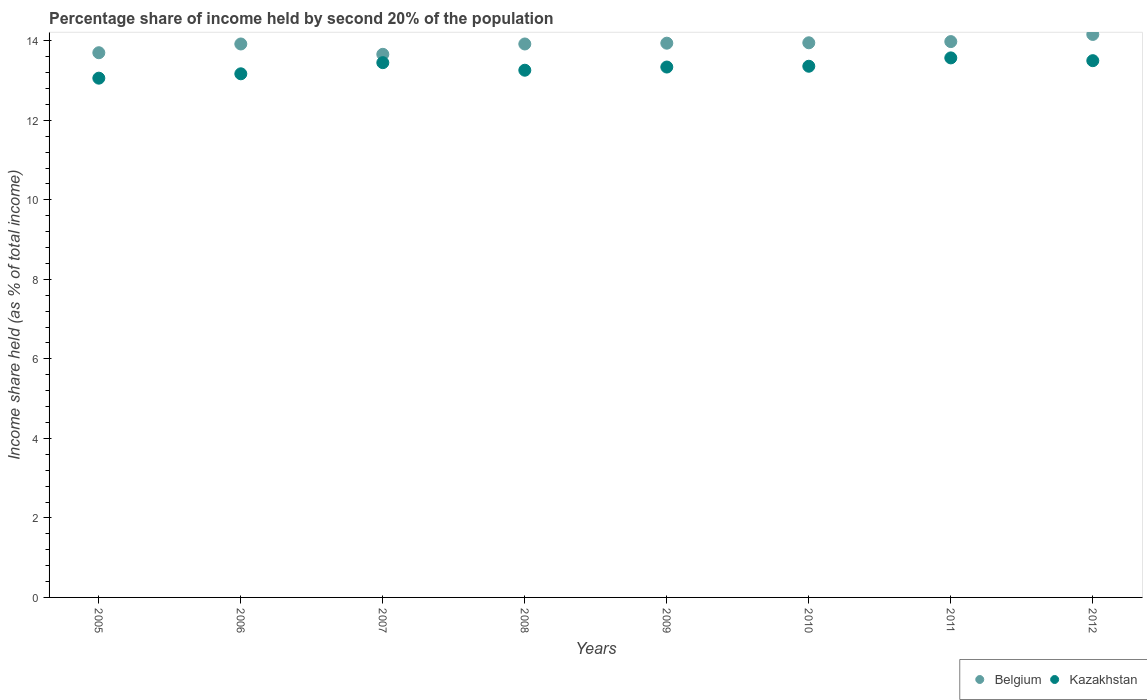How many different coloured dotlines are there?
Your answer should be compact. 2. Is the number of dotlines equal to the number of legend labels?
Give a very brief answer. Yes. What is the share of income held by second 20% of the population in Belgium in 2009?
Offer a very short reply. 13.94. Across all years, what is the maximum share of income held by second 20% of the population in Kazakhstan?
Give a very brief answer. 13.57. Across all years, what is the minimum share of income held by second 20% of the population in Kazakhstan?
Your answer should be compact. 13.06. What is the total share of income held by second 20% of the population in Kazakhstan in the graph?
Provide a succinct answer. 106.71. What is the difference between the share of income held by second 20% of the population in Belgium in 2009 and that in 2011?
Make the answer very short. -0.04. What is the difference between the share of income held by second 20% of the population in Belgium in 2009 and the share of income held by second 20% of the population in Kazakhstan in 2008?
Provide a succinct answer. 0.68. What is the average share of income held by second 20% of the population in Kazakhstan per year?
Offer a very short reply. 13.34. In the year 2010, what is the difference between the share of income held by second 20% of the population in Kazakhstan and share of income held by second 20% of the population in Belgium?
Your answer should be very brief. -0.59. What is the ratio of the share of income held by second 20% of the population in Kazakhstan in 2007 to that in 2008?
Keep it short and to the point. 1.01. What is the difference between the highest and the second highest share of income held by second 20% of the population in Kazakhstan?
Provide a short and direct response. 0.07. What is the difference between the highest and the lowest share of income held by second 20% of the population in Kazakhstan?
Provide a short and direct response. 0.51. In how many years, is the share of income held by second 20% of the population in Kazakhstan greater than the average share of income held by second 20% of the population in Kazakhstan taken over all years?
Provide a short and direct response. 5. Is the sum of the share of income held by second 20% of the population in Belgium in 2008 and 2011 greater than the maximum share of income held by second 20% of the population in Kazakhstan across all years?
Provide a short and direct response. Yes. Is the share of income held by second 20% of the population in Belgium strictly greater than the share of income held by second 20% of the population in Kazakhstan over the years?
Ensure brevity in your answer.  Yes. What is the difference between two consecutive major ticks on the Y-axis?
Provide a succinct answer. 2. Does the graph contain any zero values?
Your answer should be compact. No. Where does the legend appear in the graph?
Offer a terse response. Bottom right. How are the legend labels stacked?
Offer a terse response. Horizontal. What is the title of the graph?
Your answer should be compact. Percentage share of income held by second 20% of the population. Does "Liberia" appear as one of the legend labels in the graph?
Make the answer very short. No. What is the label or title of the X-axis?
Your response must be concise. Years. What is the label or title of the Y-axis?
Give a very brief answer. Income share held (as % of total income). What is the Income share held (as % of total income) of Belgium in 2005?
Give a very brief answer. 13.7. What is the Income share held (as % of total income) of Kazakhstan in 2005?
Provide a short and direct response. 13.06. What is the Income share held (as % of total income) in Belgium in 2006?
Your answer should be very brief. 13.92. What is the Income share held (as % of total income) in Kazakhstan in 2006?
Keep it short and to the point. 13.17. What is the Income share held (as % of total income) of Belgium in 2007?
Provide a short and direct response. 13.66. What is the Income share held (as % of total income) in Kazakhstan in 2007?
Ensure brevity in your answer.  13.45. What is the Income share held (as % of total income) in Belgium in 2008?
Make the answer very short. 13.92. What is the Income share held (as % of total income) of Kazakhstan in 2008?
Provide a succinct answer. 13.26. What is the Income share held (as % of total income) in Belgium in 2009?
Provide a succinct answer. 13.94. What is the Income share held (as % of total income) of Kazakhstan in 2009?
Give a very brief answer. 13.34. What is the Income share held (as % of total income) of Belgium in 2010?
Give a very brief answer. 13.95. What is the Income share held (as % of total income) in Kazakhstan in 2010?
Your answer should be compact. 13.36. What is the Income share held (as % of total income) in Belgium in 2011?
Give a very brief answer. 13.98. What is the Income share held (as % of total income) of Kazakhstan in 2011?
Provide a short and direct response. 13.57. What is the Income share held (as % of total income) in Belgium in 2012?
Your response must be concise. 14.16. What is the Income share held (as % of total income) of Kazakhstan in 2012?
Offer a very short reply. 13.5. Across all years, what is the maximum Income share held (as % of total income) in Belgium?
Provide a succinct answer. 14.16. Across all years, what is the maximum Income share held (as % of total income) of Kazakhstan?
Keep it short and to the point. 13.57. Across all years, what is the minimum Income share held (as % of total income) in Belgium?
Give a very brief answer. 13.66. Across all years, what is the minimum Income share held (as % of total income) of Kazakhstan?
Give a very brief answer. 13.06. What is the total Income share held (as % of total income) in Belgium in the graph?
Your response must be concise. 111.23. What is the total Income share held (as % of total income) in Kazakhstan in the graph?
Make the answer very short. 106.71. What is the difference between the Income share held (as % of total income) in Belgium in 2005 and that in 2006?
Provide a short and direct response. -0.22. What is the difference between the Income share held (as % of total income) of Kazakhstan in 2005 and that in 2006?
Your answer should be compact. -0.11. What is the difference between the Income share held (as % of total income) in Kazakhstan in 2005 and that in 2007?
Offer a terse response. -0.39. What is the difference between the Income share held (as % of total income) in Belgium in 2005 and that in 2008?
Provide a short and direct response. -0.22. What is the difference between the Income share held (as % of total income) in Belgium in 2005 and that in 2009?
Make the answer very short. -0.24. What is the difference between the Income share held (as % of total income) in Kazakhstan in 2005 and that in 2009?
Make the answer very short. -0.28. What is the difference between the Income share held (as % of total income) in Kazakhstan in 2005 and that in 2010?
Provide a short and direct response. -0.3. What is the difference between the Income share held (as % of total income) in Belgium in 2005 and that in 2011?
Give a very brief answer. -0.28. What is the difference between the Income share held (as % of total income) of Kazakhstan in 2005 and that in 2011?
Make the answer very short. -0.51. What is the difference between the Income share held (as % of total income) in Belgium in 2005 and that in 2012?
Your response must be concise. -0.46. What is the difference between the Income share held (as % of total income) of Kazakhstan in 2005 and that in 2012?
Give a very brief answer. -0.44. What is the difference between the Income share held (as % of total income) of Belgium in 2006 and that in 2007?
Make the answer very short. 0.26. What is the difference between the Income share held (as % of total income) in Kazakhstan in 2006 and that in 2007?
Offer a very short reply. -0.28. What is the difference between the Income share held (as % of total income) in Kazakhstan in 2006 and that in 2008?
Make the answer very short. -0.09. What is the difference between the Income share held (as % of total income) of Belgium in 2006 and that in 2009?
Make the answer very short. -0.02. What is the difference between the Income share held (as % of total income) in Kazakhstan in 2006 and that in 2009?
Your answer should be very brief. -0.17. What is the difference between the Income share held (as % of total income) of Belgium in 2006 and that in 2010?
Keep it short and to the point. -0.03. What is the difference between the Income share held (as % of total income) of Kazakhstan in 2006 and that in 2010?
Make the answer very short. -0.19. What is the difference between the Income share held (as % of total income) of Belgium in 2006 and that in 2011?
Provide a succinct answer. -0.06. What is the difference between the Income share held (as % of total income) in Kazakhstan in 2006 and that in 2011?
Make the answer very short. -0.4. What is the difference between the Income share held (as % of total income) of Belgium in 2006 and that in 2012?
Make the answer very short. -0.24. What is the difference between the Income share held (as % of total income) of Kazakhstan in 2006 and that in 2012?
Provide a succinct answer. -0.33. What is the difference between the Income share held (as % of total income) in Belgium in 2007 and that in 2008?
Offer a terse response. -0.26. What is the difference between the Income share held (as % of total income) in Kazakhstan in 2007 and that in 2008?
Keep it short and to the point. 0.19. What is the difference between the Income share held (as % of total income) of Belgium in 2007 and that in 2009?
Your answer should be very brief. -0.28. What is the difference between the Income share held (as % of total income) of Kazakhstan in 2007 and that in 2009?
Give a very brief answer. 0.11. What is the difference between the Income share held (as % of total income) in Belgium in 2007 and that in 2010?
Offer a terse response. -0.29. What is the difference between the Income share held (as % of total income) in Kazakhstan in 2007 and that in 2010?
Offer a terse response. 0.09. What is the difference between the Income share held (as % of total income) of Belgium in 2007 and that in 2011?
Offer a very short reply. -0.32. What is the difference between the Income share held (as % of total income) in Kazakhstan in 2007 and that in 2011?
Your answer should be compact. -0.12. What is the difference between the Income share held (as % of total income) in Belgium in 2007 and that in 2012?
Provide a succinct answer. -0.5. What is the difference between the Income share held (as % of total income) of Kazakhstan in 2007 and that in 2012?
Your answer should be very brief. -0.05. What is the difference between the Income share held (as % of total income) in Belgium in 2008 and that in 2009?
Your answer should be compact. -0.02. What is the difference between the Income share held (as % of total income) in Kazakhstan in 2008 and that in 2009?
Provide a short and direct response. -0.08. What is the difference between the Income share held (as % of total income) in Belgium in 2008 and that in 2010?
Your answer should be compact. -0.03. What is the difference between the Income share held (as % of total income) of Kazakhstan in 2008 and that in 2010?
Offer a very short reply. -0.1. What is the difference between the Income share held (as % of total income) in Belgium in 2008 and that in 2011?
Keep it short and to the point. -0.06. What is the difference between the Income share held (as % of total income) of Kazakhstan in 2008 and that in 2011?
Keep it short and to the point. -0.31. What is the difference between the Income share held (as % of total income) of Belgium in 2008 and that in 2012?
Offer a terse response. -0.24. What is the difference between the Income share held (as % of total income) of Kazakhstan in 2008 and that in 2012?
Your answer should be compact. -0.24. What is the difference between the Income share held (as % of total income) of Belgium in 2009 and that in 2010?
Your answer should be very brief. -0.01. What is the difference between the Income share held (as % of total income) in Kazakhstan in 2009 and that in 2010?
Offer a terse response. -0.02. What is the difference between the Income share held (as % of total income) of Belgium in 2009 and that in 2011?
Provide a succinct answer. -0.04. What is the difference between the Income share held (as % of total income) in Kazakhstan in 2009 and that in 2011?
Provide a succinct answer. -0.23. What is the difference between the Income share held (as % of total income) of Belgium in 2009 and that in 2012?
Provide a succinct answer. -0.22. What is the difference between the Income share held (as % of total income) of Kazakhstan in 2009 and that in 2012?
Ensure brevity in your answer.  -0.16. What is the difference between the Income share held (as % of total income) in Belgium in 2010 and that in 2011?
Offer a very short reply. -0.03. What is the difference between the Income share held (as % of total income) in Kazakhstan in 2010 and that in 2011?
Keep it short and to the point. -0.21. What is the difference between the Income share held (as % of total income) of Belgium in 2010 and that in 2012?
Offer a very short reply. -0.21. What is the difference between the Income share held (as % of total income) in Kazakhstan in 2010 and that in 2012?
Ensure brevity in your answer.  -0.14. What is the difference between the Income share held (as % of total income) in Belgium in 2011 and that in 2012?
Your answer should be very brief. -0.18. What is the difference between the Income share held (as % of total income) of Kazakhstan in 2011 and that in 2012?
Provide a short and direct response. 0.07. What is the difference between the Income share held (as % of total income) of Belgium in 2005 and the Income share held (as % of total income) of Kazakhstan in 2006?
Provide a succinct answer. 0.53. What is the difference between the Income share held (as % of total income) in Belgium in 2005 and the Income share held (as % of total income) in Kazakhstan in 2008?
Offer a terse response. 0.44. What is the difference between the Income share held (as % of total income) of Belgium in 2005 and the Income share held (as % of total income) of Kazakhstan in 2009?
Offer a terse response. 0.36. What is the difference between the Income share held (as % of total income) of Belgium in 2005 and the Income share held (as % of total income) of Kazakhstan in 2010?
Your answer should be compact. 0.34. What is the difference between the Income share held (as % of total income) of Belgium in 2005 and the Income share held (as % of total income) of Kazakhstan in 2011?
Make the answer very short. 0.13. What is the difference between the Income share held (as % of total income) of Belgium in 2006 and the Income share held (as % of total income) of Kazakhstan in 2007?
Provide a short and direct response. 0.47. What is the difference between the Income share held (as % of total income) of Belgium in 2006 and the Income share held (as % of total income) of Kazakhstan in 2008?
Your response must be concise. 0.66. What is the difference between the Income share held (as % of total income) in Belgium in 2006 and the Income share held (as % of total income) in Kazakhstan in 2009?
Ensure brevity in your answer.  0.58. What is the difference between the Income share held (as % of total income) in Belgium in 2006 and the Income share held (as % of total income) in Kazakhstan in 2010?
Provide a succinct answer. 0.56. What is the difference between the Income share held (as % of total income) in Belgium in 2006 and the Income share held (as % of total income) in Kazakhstan in 2012?
Your response must be concise. 0.42. What is the difference between the Income share held (as % of total income) of Belgium in 2007 and the Income share held (as % of total income) of Kazakhstan in 2009?
Provide a succinct answer. 0.32. What is the difference between the Income share held (as % of total income) in Belgium in 2007 and the Income share held (as % of total income) in Kazakhstan in 2010?
Offer a terse response. 0.3. What is the difference between the Income share held (as % of total income) of Belgium in 2007 and the Income share held (as % of total income) of Kazakhstan in 2011?
Ensure brevity in your answer.  0.09. What is the difference between the Income share held (as % of total income) of Belgium in 2007 and the Income share held (as % of total income) of Kazakhstan in 2012?
Provide a short and direct response. 0.16. What is the difference between the Income share held (as % of total income) of Belgium in 2008 and the Income share held (as % of total income) of Kazakhstan in 2009?
Offer a terse response. 0.58. What is the difference between the Income share held (as % of total income) in Belgium in 2008 and the Income share held (as % of total income) in Kazakhstan in 2010?
Your answer should be compact. 0.56. What is the difference between the Income share held (as % of total income) in Belgium in 2008 and the Income share held (as % of total income) in Kazakhstan in 2012?
Offer a terse response. 0.42. What is the difference between the Income share held (as % of total income) in Belgium in 2009 and the Income share held (as % of total income) in Kazakhstan in 2010?
Your response must be concise. 0.58. What is the difference between the Income share held (as % of total income) in Belgium in 2009 and the Income share held (as % of total income) in Kazakhstan in 2011?
Make the answer very short. 0.37. What is the difference between the Income share held (as % of total income) in Belgium in 2009 and the Income share held (as % of total income) in Kazakhstan in 2012?
Provide a short and direct response. 0.44. What is the difference between the Income share held (as % of total income) of Belgium in 2010 and the Income share held (as % of total income) of Kazakhstan in 2011?
Give a very brief answer. 0.38. What is the difference between the Income share held (as % of total income) in Belgium in 2010 and the Income share held (as % of total income) in Kazakhstan in 2012?
Give a very brief answer. 0.45. What is the difference between the Income share held (as % of total income) in Belgium in 2011 and the Income share held (as % of total income) in Kazakhstan in 2012?
Give a very brief answer. 0.48. What is the average Income share held (as % of total income) in Belgium per year?
Provide a succinct answer. 13.9. What is the average Income share held (as % of total income) of Kazakhstan per year?
Offer a very short reply. 13.34. In the year 2005, what is the difference between the Income share held (as % of total income) in Belgium and Income share held (as % of total income) in Kazakhstan?
Provide a succinct answer. 0.64. In the year 2007, what is the difference between the Income share held (as % of total income) of Belgium and Income share held (as % of total income) of Kazakhstan?
Offer a very short reply. 0.21. In the year 2008, what is the difference between the Income share held (as % of total income) of Belgium and Income share held (as % of total income) of Kazakhstan?
Give a very brief answer. 0.66. In the year 2009, what is the difference between the Income share held (as % of total income) of Belgium and Income share held (as % of total income) of Kazakhstan?
Your answer should be very brief. 0.6. In the year 2010, what is the difference between the Income share held (as % of total income) in Belgium and Income share held (as % of total income) in Kazakhstan?
Give a very brief answer. 0.59. In the year 2011, what is the difference between the Income share held (as % of total income) of Belgium and Income share held (as % of total income) of Kazakhstan?
Your response must be concise. 0.41. In the year 2012, what is the difference between the Income share held (as % of total income) in Belgium and Income share held (as % of total income) in Kazakhstan?
Make the answer very short. 0.66. What is the ratio of the Income share held (as % of total income) of Belgium in 2005 to that in 2006?
Your answer should be compact. 0.98. What is the ratio of the Income share held (as % of total income) of Kazakhstan in 2005 to that in 2007?
Give a very brief answer. 0.97. What is the ratio of the Income share held (as % of total income) of Belgium in 2005 to that in 2008?
Your response must be concise. 0.98. What is the ratio of the Income share held (as % of total income) in Kazakhstan in 2005 to that in 2008?
Your answer should be very brief. 0.98. What is the ratio of the Income share held (as % of total income) in Belgium in 2005 to that in 2009?
Ensure brevity in your answer.  0.98. What is the ratio of the Income share held (as % of total income) of Belgium in 2005 to that in 2010?
Your answer should be very brief. 0.98. What is the ratio of the Income share held (as % of total income) of Kazakhstan in 2005 to that in 2010?
Ensure brevity in your answer.  0.98. What is the ratio of the Income share held (as % of total income) in Kazakhstan in 2005 to that in 2011?
Your response must be concise. 0.96. What is the ratio of the Income share held (as % of total income) in Belgium in 2005 to that in 2012?
Give a very brief answer. 0.97. What is the ratio of the Income share held (as % of total income) of Kazakhstan in 2005 to that in 2012?
Give a very brief answer. 0.97. What is the ratio of the Income share held (as % of total income) in Belgium in 2006 to that in 2007?
Make the answer very short. 1.02. What is the ratio of the Income share held (as % of total income) in Kazakhstan in 2006 to that in 2007?
Ensure brevity in your answer.  0.98. What is the ratio of the Income share held (as % of total income) of Kazakhstan in 2006 to that in 2009?
Keep it short and to the point. 0.99. What is the ratio of the Income share held (as % of total income) in Belgium in 2006 to that in 2010?
Keep it short and to the point. 1. What is the ratio of the Income share held (as % of total income) of Kazakhstan in 2006 to that in 2010?
Offer a very short reply. 0.99. What is the ratio of the Income share held (as % of total income) in Belgium in 2006 to that in 2011?
Provide a short and direct response. 1. What is the ratio of the Income share held (as % of total income) in Kazakhstan in 2006 to that in 2011?
Provide a short and direct response. 0.97. What is the ratio of the Income share held (as % of total income) of Belgium in 2006 to that in 2012?
Provide a short and direct response. 0.98. What is the ratio of the Income share held (as % of total income) of Kazakhstan in 2006 to that in 2012?
Your answer should be very brief. 0.98. What is the ratio of the Income share held (as % of total income) in Belgium in 2007 to that in 2008?
Make the answer very short. 0.98. What is the ratio of the Income share held (as % of total income) of Kazakhstan in 2007 to that in 2008?
Make the answer very short. 1.01. What is the ratio of the Income share held (as % of total income) of Belgium in 2007 to that in 2009?
Provide a succinct answer. 0.98. What is the ratio of the Income share held (as % of total income) in Kazakhstan in 2007 to that in 2009?
Provide a short and direct response. 1.01. What is the ratio of the Income share held (as % of total income) of Belgium in 2007 to that in 2010?
Offer a terse response. 0.98. What is the ratio of the Income share held (as % of total income) of Belgium in 2007 to that in 2011?
Your answer should be compact. 0.98. What is the ratio of the Income share held (as % of total income) of Belgium in 2007 to that in 2012?
Offer a very short reply. 0.96. What is the ratio of the Income share held (as % of total income) in Kazakhstan in 2007 to that in 2012?
Offer a terse response. 1. What is the ratio of the Income share held (as % of total income) of Kazakhstan in 2008 to that in 2010?
Offer a very short reply. 0.99. What is the ratio of the Income share held (as % of total income) in Belgium in 2008 to that in 2011?
Provide a short and direct response. 1. What is the ratio of the Income share held (as % of total income) of Kazakhstan in 2008 to that in 2011?
Keep it short and to the point. 0.98. What is the ratio of the Income share held (as % of total income) in Belgium in 2008 to that in 2012?
Provide a short and direct response. 0.98. What is the ratio of the Income share held (as % of total income) of Kazakhstan in 2008 to that in 2012?
Ensure brevity in your answer.  0.98. What is the ratio of the Income share held (as % of total income) in Belgium in 2009 to that in 2011?
Offer a terse response. 1. What is the ratio of the Income share held (as % of total income) in Kazakhstan in 2009 to that in 2011?
Offer a very short reply. 0.98. What is the ratio of the Income share held (as % of total income) of Belgium in 2009 to that in 2012?
Give a very brief answer. 0.98. What is the ratio of the Income share held (as % of total income) in Kazakhstan in 2009 to that in 2012?
Provide a succinct answer. 0.99. What is the ratio of the Income share held (as % of total income) of Kazakhstan in 2010 to that in 2011?
Provide a succinct answer. 0.98. What is the ratio of the Income share held (as % of total income) in Belgium in 2010 to that in 2012?
Provide a succinct answer. 0.99. What is the ratio of the Income share held (as % of total income) in Kazakhstan in 2010 to that in 2012?
Ensure brevity in your answer.  0.99. What is the ratio of the Income share held (as % of total income) in Belgium in 2011 to that in 2012?
Your answer should be very brief. 0.99. What is the ratio of the Income share held (as % of total income) of Kazakhstan in 2011 to that in 2012?
Your answer should be compact. 1.01. What is the difference between the highest and the second highest Income share held (as % of total income) in Belgium?
Your answer should be very brief. 0.18. What is the difference between the highest and the second highest Income share held (as % of total income) in Kazakhstan?
Your answer should be very brief. 0.07. What is the difference between the highest and the lowest Income share held (as % of total income) of Kazakhstan?
Keep it short and to the point. 0.51. 